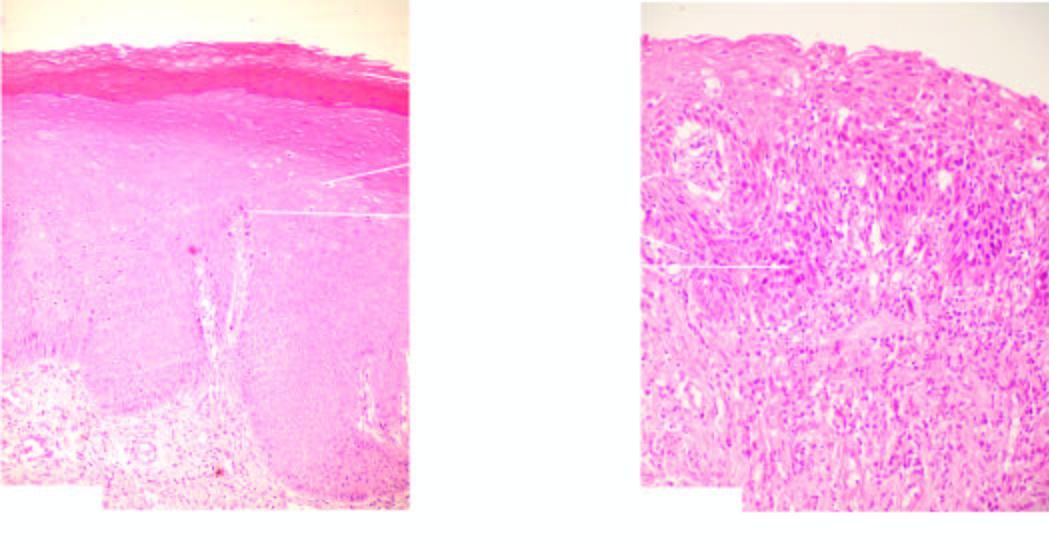s formation of granulation tissue no invasion across the basement membrane?
Answer the question using a single word or phrase. No 